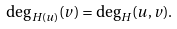Convert formula to latex. <formula><loc_0><loc_0><loc_500><loc_500>\deg _ { H ( u ) } ( v ) = \deg _ { H } ( u , v ) .</formula> 